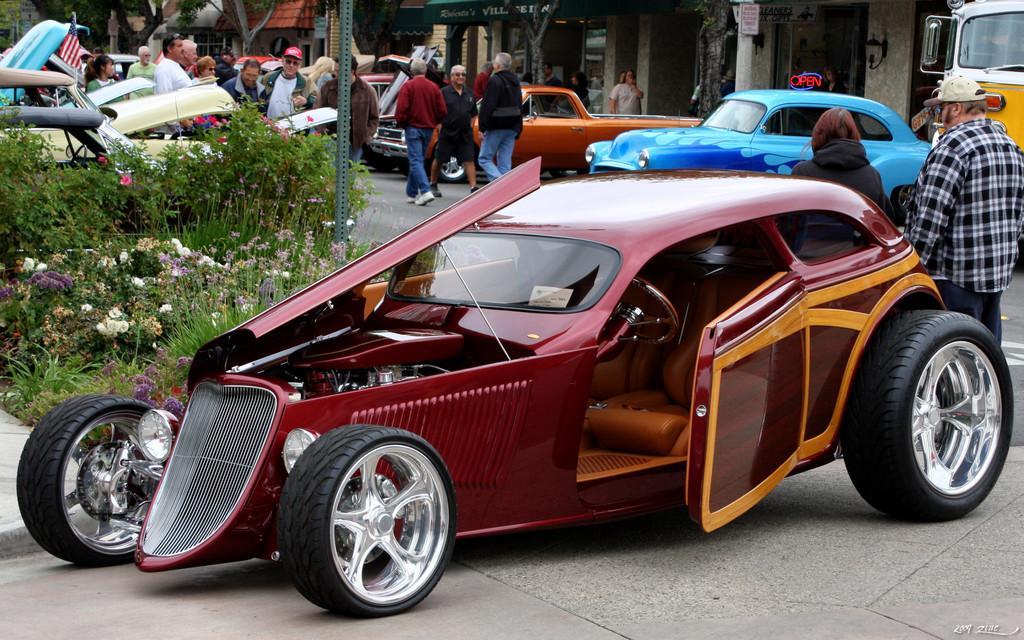How would you summarize this image in a sentence or two? In this picture there is a car in the center of the image and there are other cars, people, and trees in the background area of the image and there are flower plants on the left side of the image. 